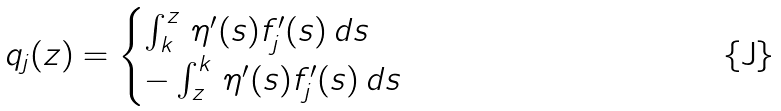Convert formula to latex. <formula><loc_0><loc_0><loc_500><loc_500>q _ { j } ( z ) = \begin{cases} \int _ { k } ^ { z } \, \eta ^ { \prime } ( s ) f _ { j } ^ { \prime } ( s ) \, d s & \\ - \int _ { z } ^ { k } \, \eta ^ { \prime } ( s ) f _ { j } ^ { \prime } ( s ) \, d s & \end{cases}</formula> 